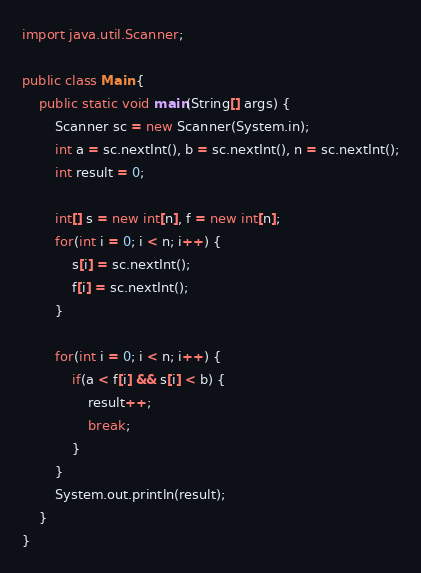<code> <loc_0><loc_0><loc_500><loc_500><_Java_>import java.util.Scanner;

public class Main {
    public static void main(String[] args) {
        Scanner sc = new Scanner(System.in);
        int a = sc.nextInt(), b = sc.nextInt(), n = sc.nextInt();
        int result = 0;

        int[] s = new int[n], f = new int[n];
        for(int i = 0; i < n; i++) {
            s[i] = sc.nextInt();
            f[i] = sc.nextInt();
        }

        for(int i = 0; i < n; i++) {
            if(a < f[i] && s[i] < b) {
                result++;
                break;
            }
        }
        System.out.println(result);
    }
}</code> 